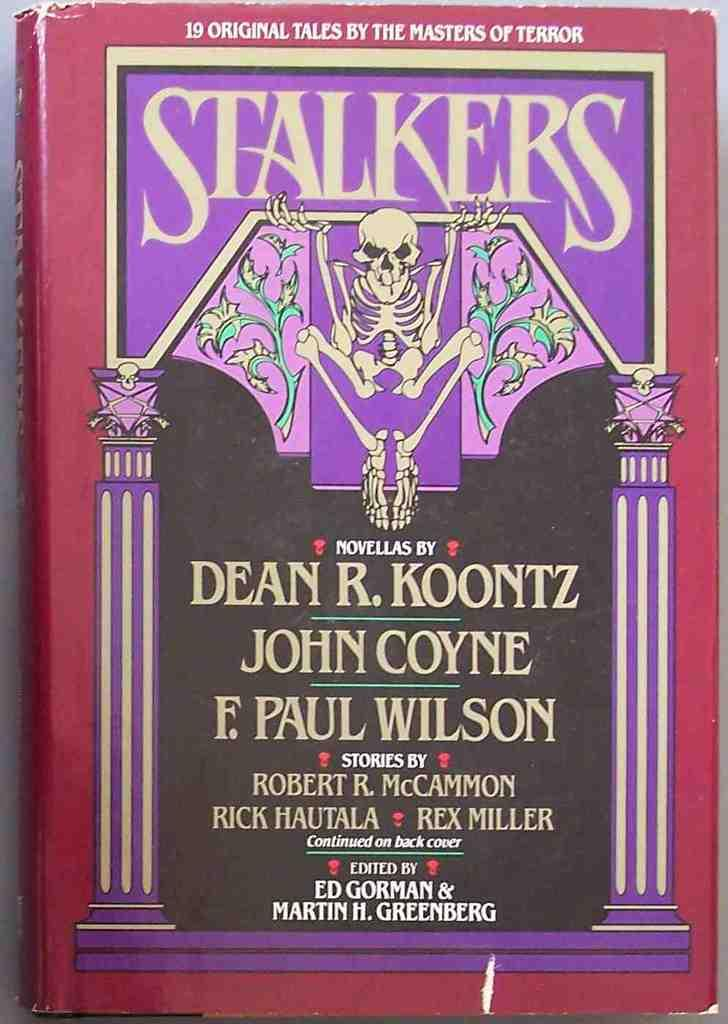<image>
Relay a brief, clear account of the picture shown. Stalkers 19 original tales by the masters of terror. 